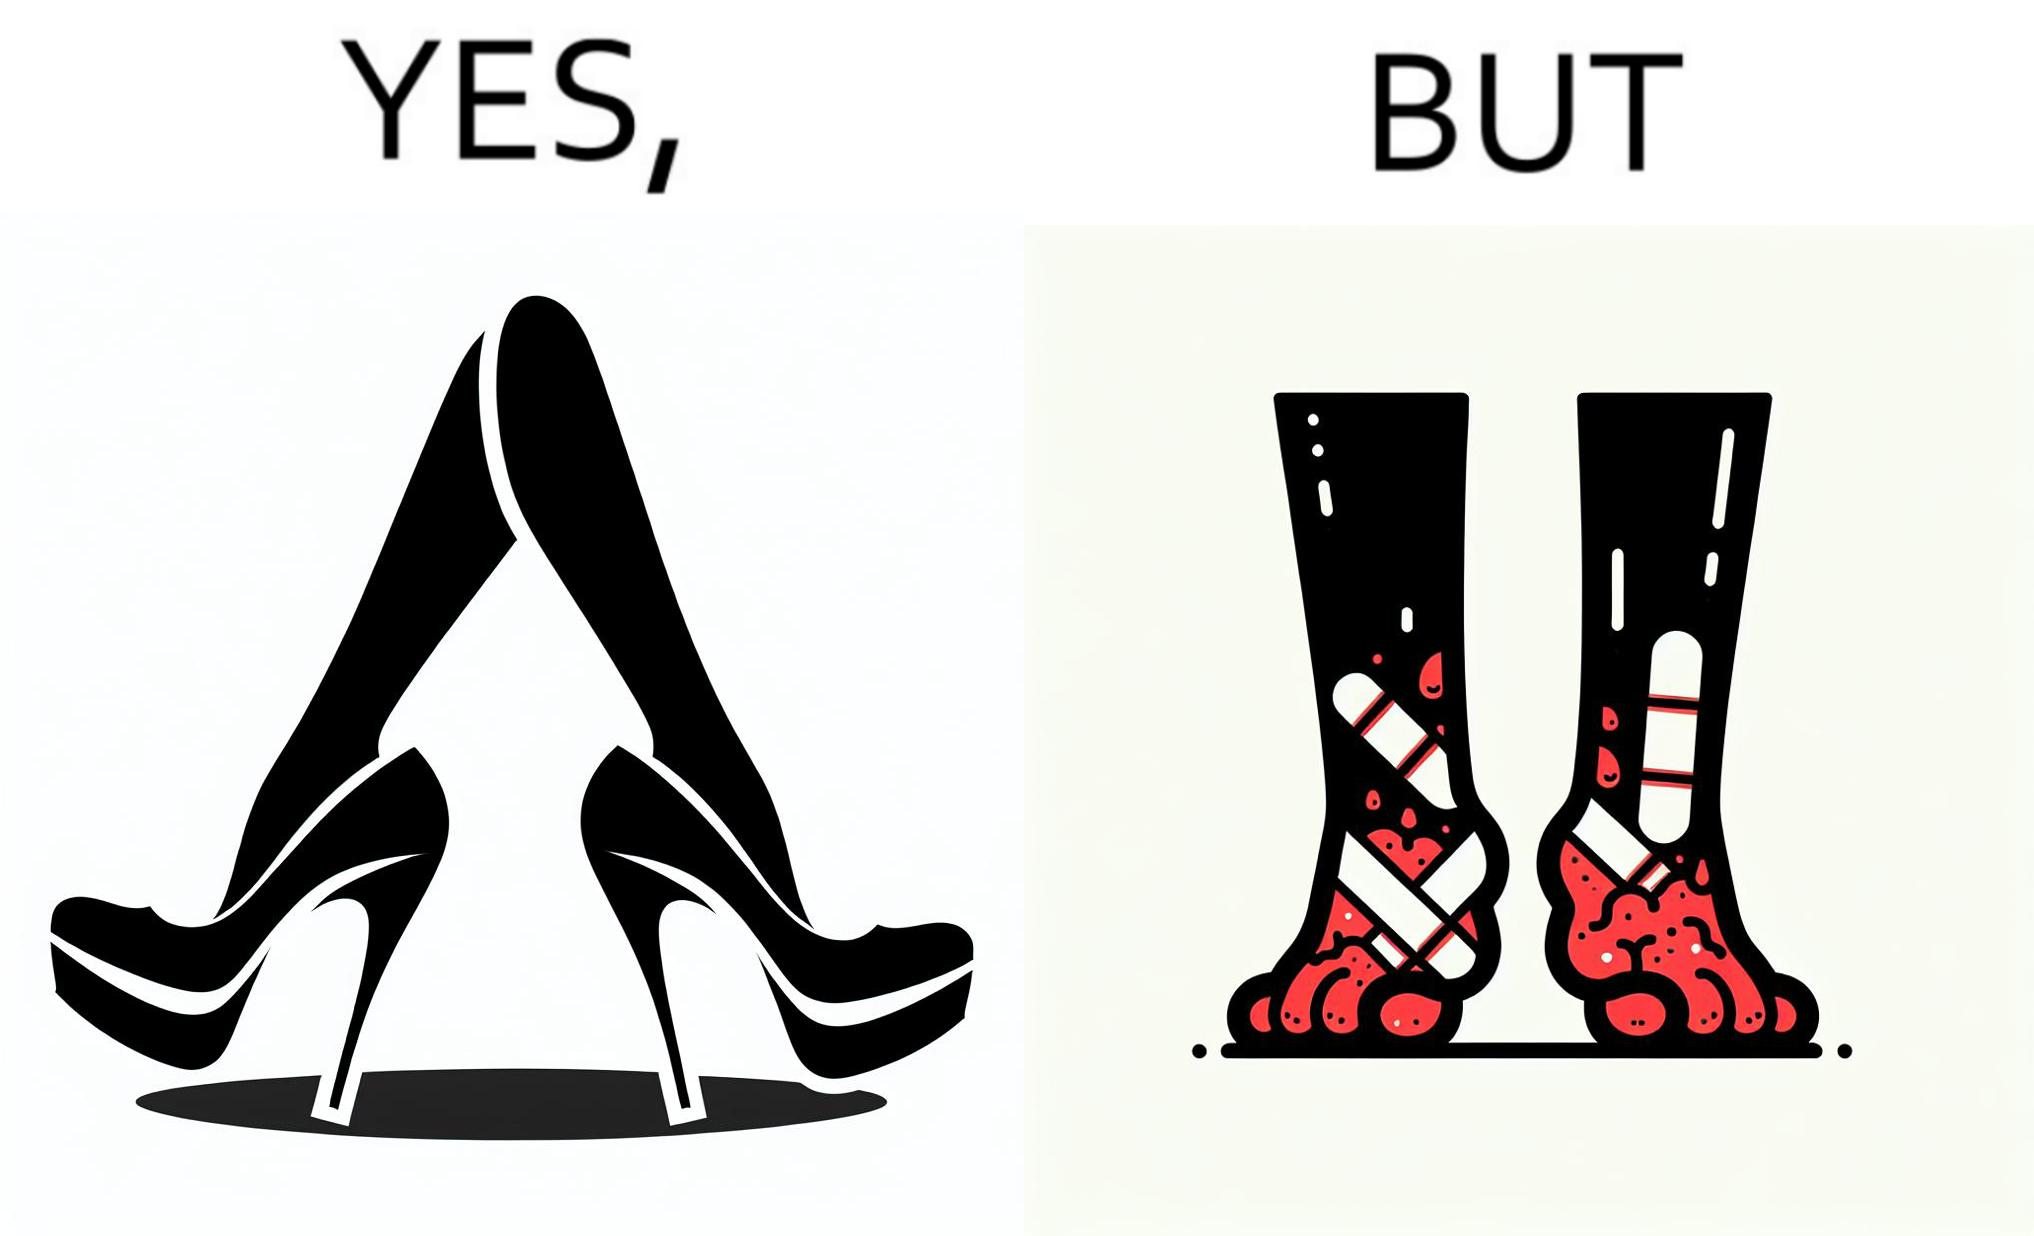Would you classify this image as satirical? Yes, this image is satirical. 